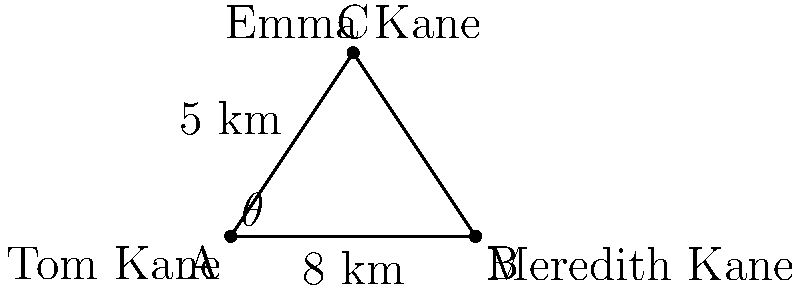In the political drama "Boss", Mayor Tom Kane needs to determine the distance between his daughter Emma's location and his wife Meredith's location. Tom knows that Emma is 5 km away from him at an angle of $\theta$ from the straight line between him and Meredith. If Tom and Meredith are 8 km apart, and $\sin \theta = \frac{3}{5}$, what is the distance between Emma and Meredith? Let's approach this step-by-step:

1) First, we need to identify the triangle formed by Tom (A), Meredith (B), and Emma (C).

2) We're given that:
   - AB = 8 km (distance between Tom and Meredith)
   - AC = 5 km (distance between Tom and Emma)
   - $\sin \theta = \frac{3}{5}$

3) To find BC (distance between Emma and Meredith), we can use the law of cosines:

   $BC^2 = AB^2 + AC^2 - 2(AB)(AC)\cos \theta$

4) We know AB and AC, but we need to find $\cos \theta$. We can do this using the Pythagorean identity:

   $\sin^2 \theta + \cos^2 \theta = 1$

5) Substituting the known value of $\sin \theta$:

   $(\frac{3}{5})^2 + \cos^2 \theta = 1$
   $\frac{9}{25} + \cos^2 \theta = 1$
   $\cos^2 \theta = 1 - \frac{9}{25} = \frac{16}{25}$
   $\cos \theta = \frac{4}{5}$

6) Now we can apply the law of cosines:

   $BC^2 = 8^2 + 5^2 - 2(8)(5)\cos \theta$
   $BC^2 = 64 + 25 - 80(\frac{4}{5})$
   $BC^2 = 89 - 64 = 25$

7) Taking the square root of both sides:

   $BC = 5$ km

Therefore, the distance between Emma and Meredith is 5 km.
Answer: 5 km 